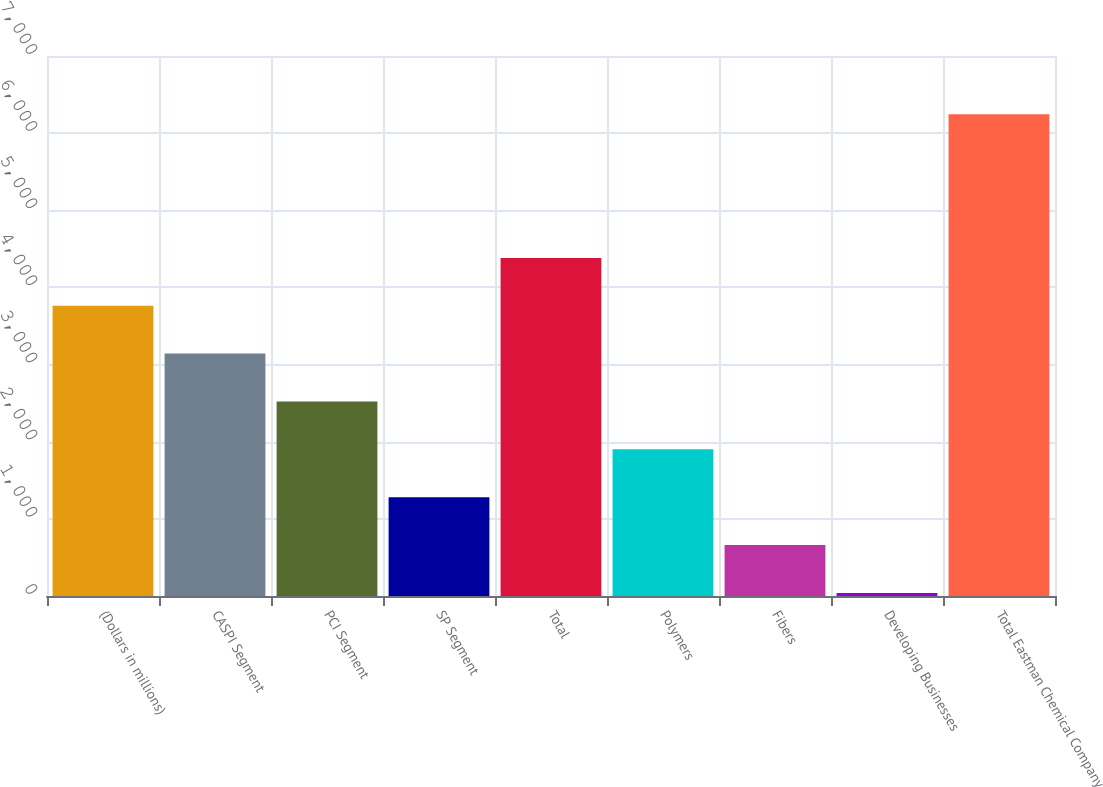Convert chart to OTSL. <chart><loc_0><loc_0><loc_500><loc_500><bar_chart><fcel>(Dollars in millions)<fcel>CASPI Segment<fcel>PCI Segment<fcel>SP Segment<fcel>Total<fcel>Polymers<fcel>Fibers<fcel>Developing Businesses<fcel>Total Eastman Chemical Company<nl><fcel>3762.4<fcel>3142<fcel>2521.6<fcel>1280.8<fcel>4382.8<fcel>1901.2<fcel>660.4<fcel>40<fcel>6244<nl></chart> 